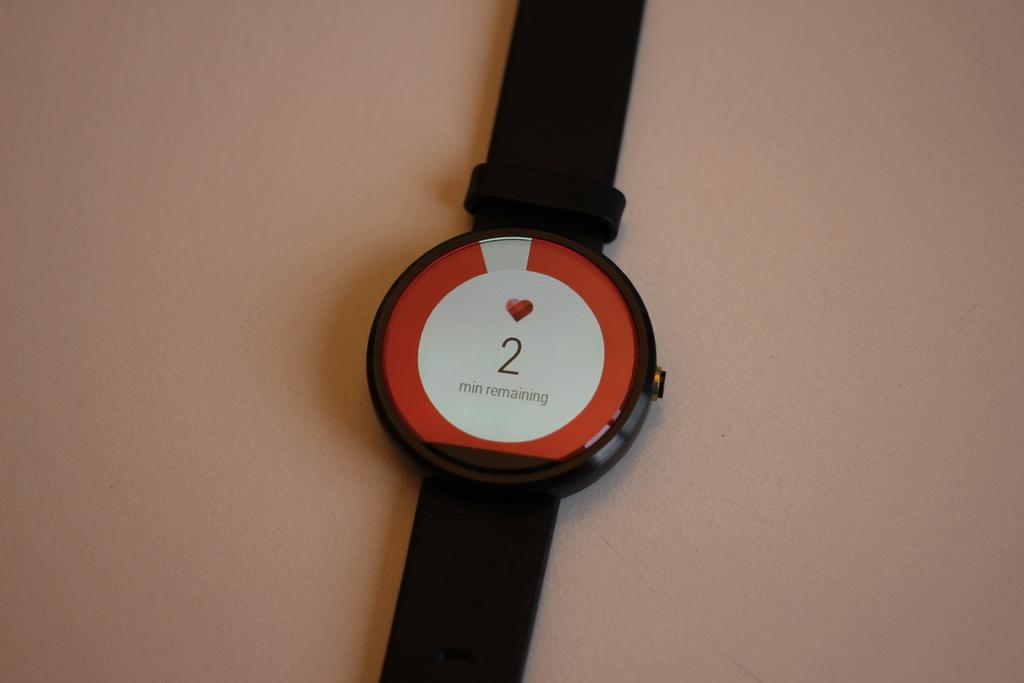<image>
Write a terse but informative summary of the picture. A watch that has a heart stone and 2 minutes remaining 